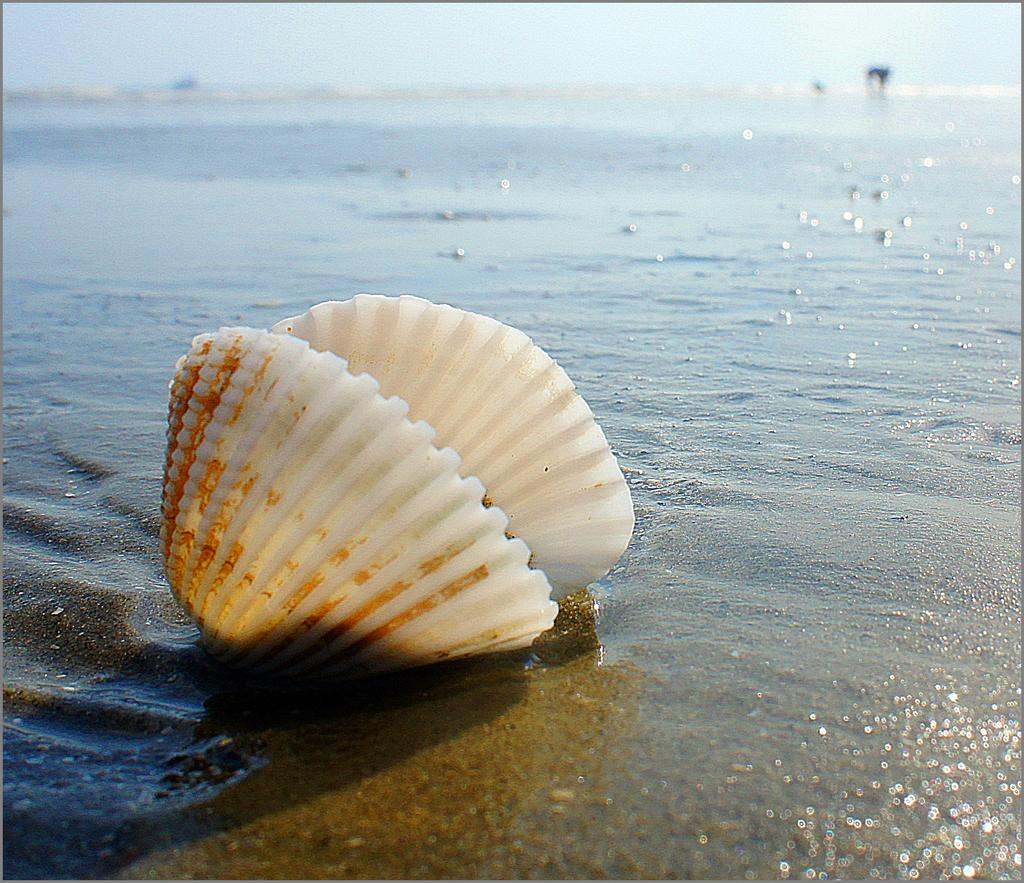What object can be seen in the image? There is a shell in the image. What can be seen in the background of the image? There is water visible in the background of the image. What type of wire is holding the owl in the image? There is no wire or owl present in the image; it only features a shell and water in the background. 